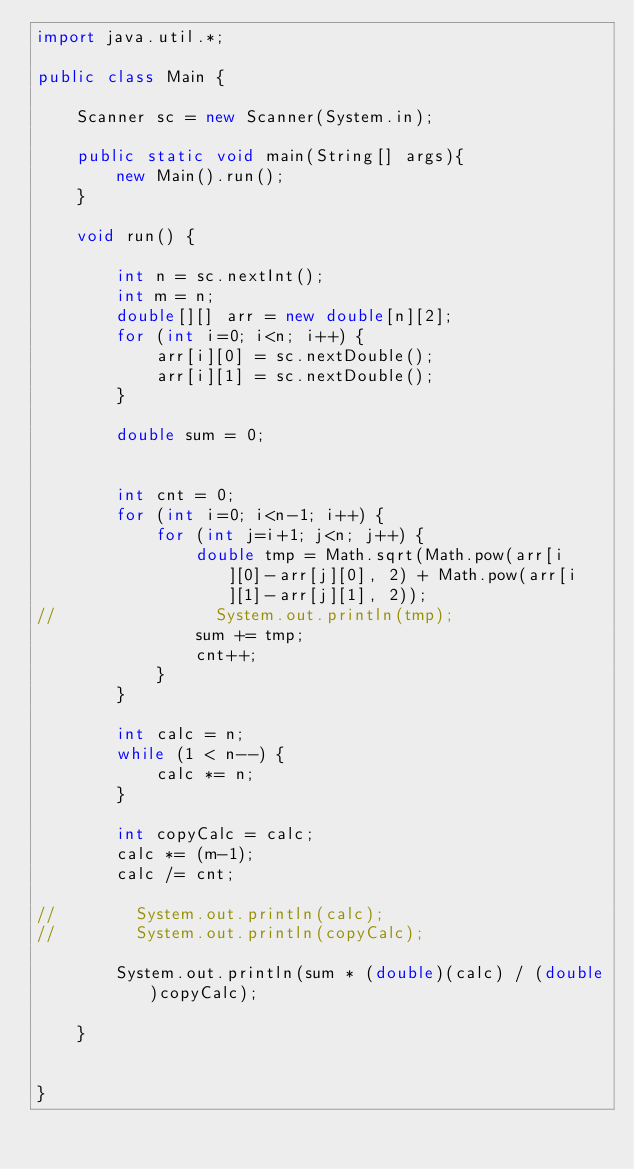<code> <loc_0><loc_0><loc_500><loc_500><_Java_>import java.util.*;

public class Main {

    Scanner sc = new Scanner(System.in);

    public static void main(String[] args){
        new Main().run();
    }

    void run() {

        int n = sc.nextInt();
        int m = n;
        double[][] arr = new double[n][2];
        for (int i=0; i<n; i++) {
            arr[i][0] = sc.nextDouble();
            arr[i][1] = sc.nextDouble();
        }

        double sum = 0;


        int cnt = 0;
        for (int i=0; i<n-1; i++) {
            for (int j=i+1; j<n; j++) {
                double tmp = Math.sqrt(Math.pow(arr[i][0]-arr[j][0], 2) + Math.pow(arr[i][1]-arr[j][1], 2));
//                System.out.println(tmp);
                sum += tmp;
                cnt++;
            }
        }

        int calc = n;
        while (1 < n--) {
            calc *= n;
        }

        int copyCalc = calc;
        calc *= (m-1);
        calc /= cnt;

//        System.out.println(calc);
//        System.out.println(copyCalc);

        System.out.println(sum * (double)(calc) / (double)copyCalc);

    }


}
</code> 